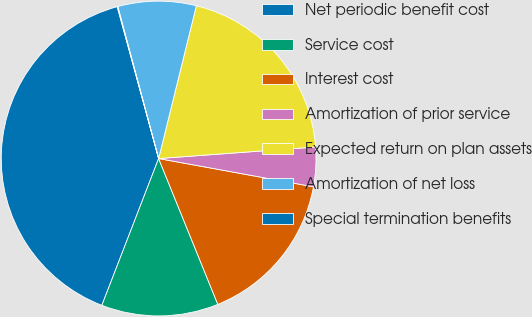Convert chart to OTSL. <chart><loc_0><loc_0><loc_500><loc_500><pie_chart><fcel>Net periodic benefit cost<fcel>Service cost<fcel>Interest cost<fcel>Amortization of prior service<fcel>Expected return on plan assets<fcel>Amortization of net loss<fcel>Special termination benefits<nl><fcel>39.89%<fcel>12.01%<fcel>15.99%<fcel>4.04%<fcel>19.98%<fcel>8.03%<fcel>0.06%<nl></chart> 